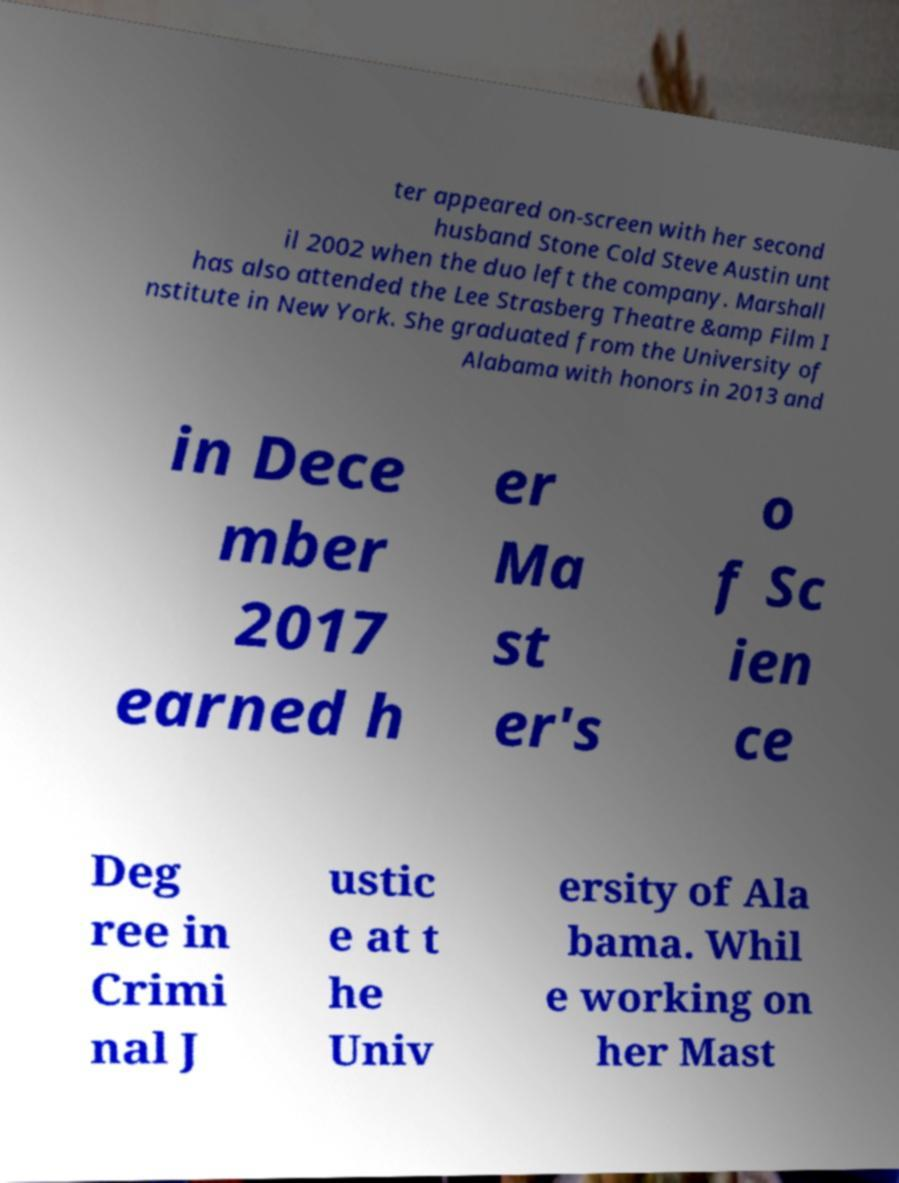Please identify and transcribe the text found in this image. ter appeared on-screen with her second husband Stone Cold Steve Austin unt il 2002 when the duo left the company. Marshall has also attended the Lee Strasberg Theatre &amp Film I nstitute in New York. She graduated from the University of Alabama with honors in 2013 and in Dece mber 2017 earned h er Ma st er's o f Sc ien ce Deg ree in Crimi nal J ustic e at t he Univ ersity of Ala bama. Whil e working on her Mast 